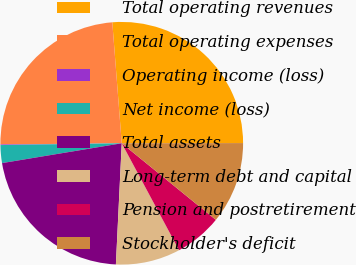Convert chart. <chart><loc_0><loc_0><loc_500><loc_500><pie_chart><fcel>Total operating revenues<fcel>Total operating expenses<fcel>Operating income (loss)<fcel>Net income (loss)<fcel>Total assets<fcel>Long-term debt and capital<fcel>Pension and postretirement<fcel>Stockholder's deficit<nl><fcel>26.22%<fcel>23.92%<fcel>0.08%<fcel>2.38%<fcel>21.62%<fcel>8.6%<fcel>6.3%<fcel>10.9%<nl></chart> 